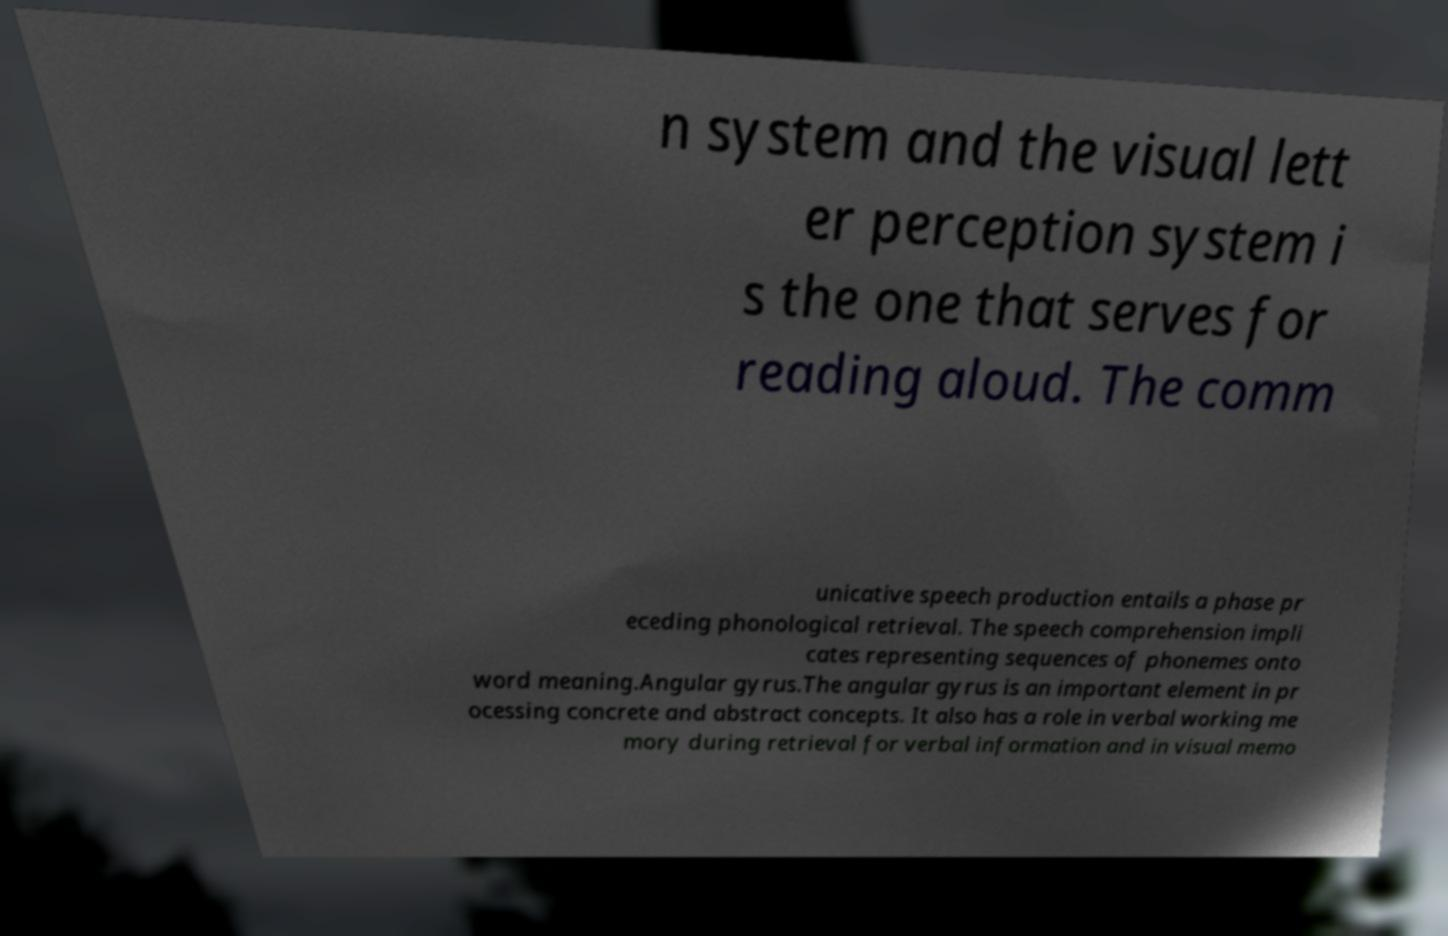I need the written content from this picture converted into text. Can you do that? n system and the visual lett er perception system i s the one that serves for reading aloud. The comm unicative speech production entails a phase pr eceding phonological retrieval. The speech comprehension impli cates representing sequences of phonemes onto word meaning.Angular gyrus.The angular gyrus is an important element in pr ocessing concrete and abstract concepts. It also has a role in verbal working me mory during retrieval for verbal information and in visual memo 